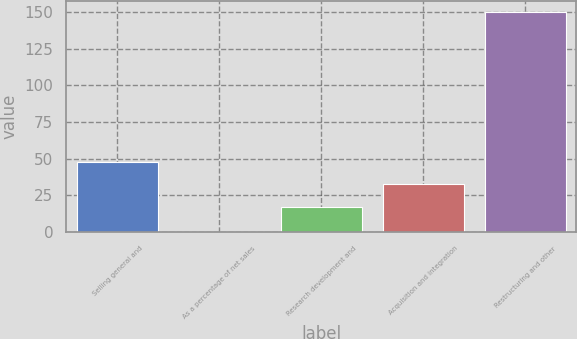Convert chart. <chart><loc_0><loc_0><loc_500><loc_500><bar_chart><fcel>Selling general and<fcel>As a percentage of net sales<fcel>Research development and<fcel>Acquisition and integration<fcel>Restructuring and other<nl><fcel>47.97<fcel>0.3<fcel>17<fcel>33<fcel>150<nl></chart> 